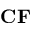Convert formula to latex. <formula><loc_0><loc_0><loc_500><loc_500>C F</formula> 